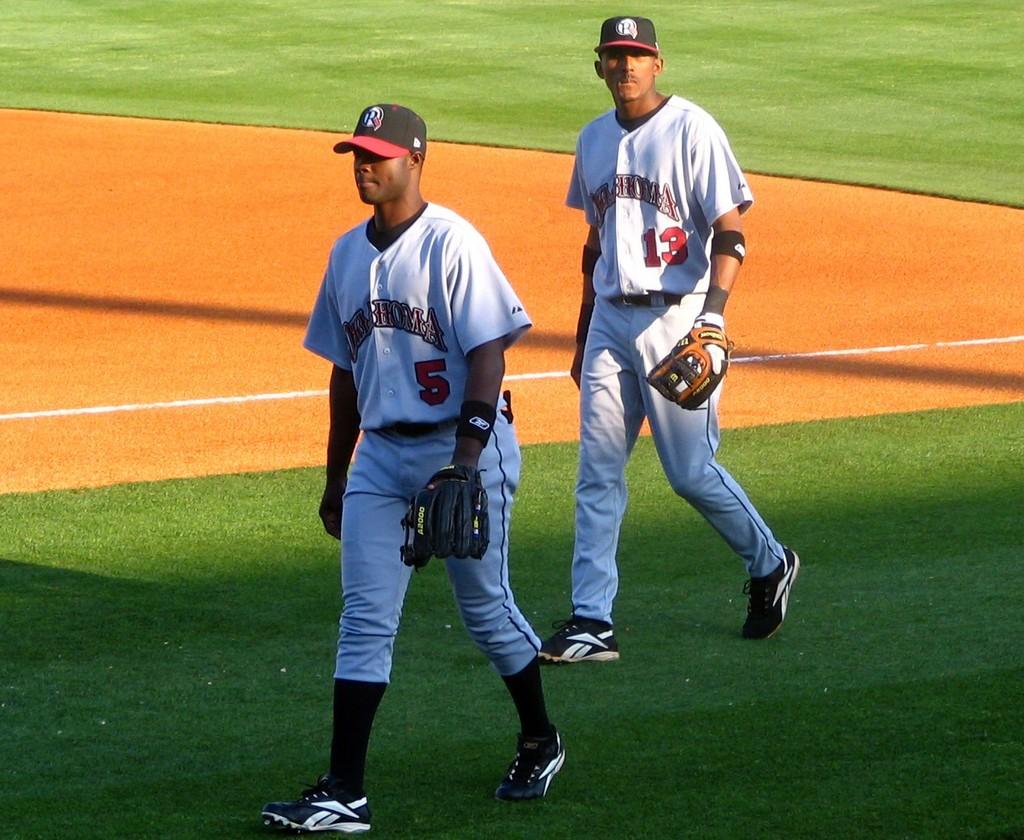What number is the player in the back?
Keep it short and to the point. 13. What letter is on the players' hats?
Make the answer very short. R. 